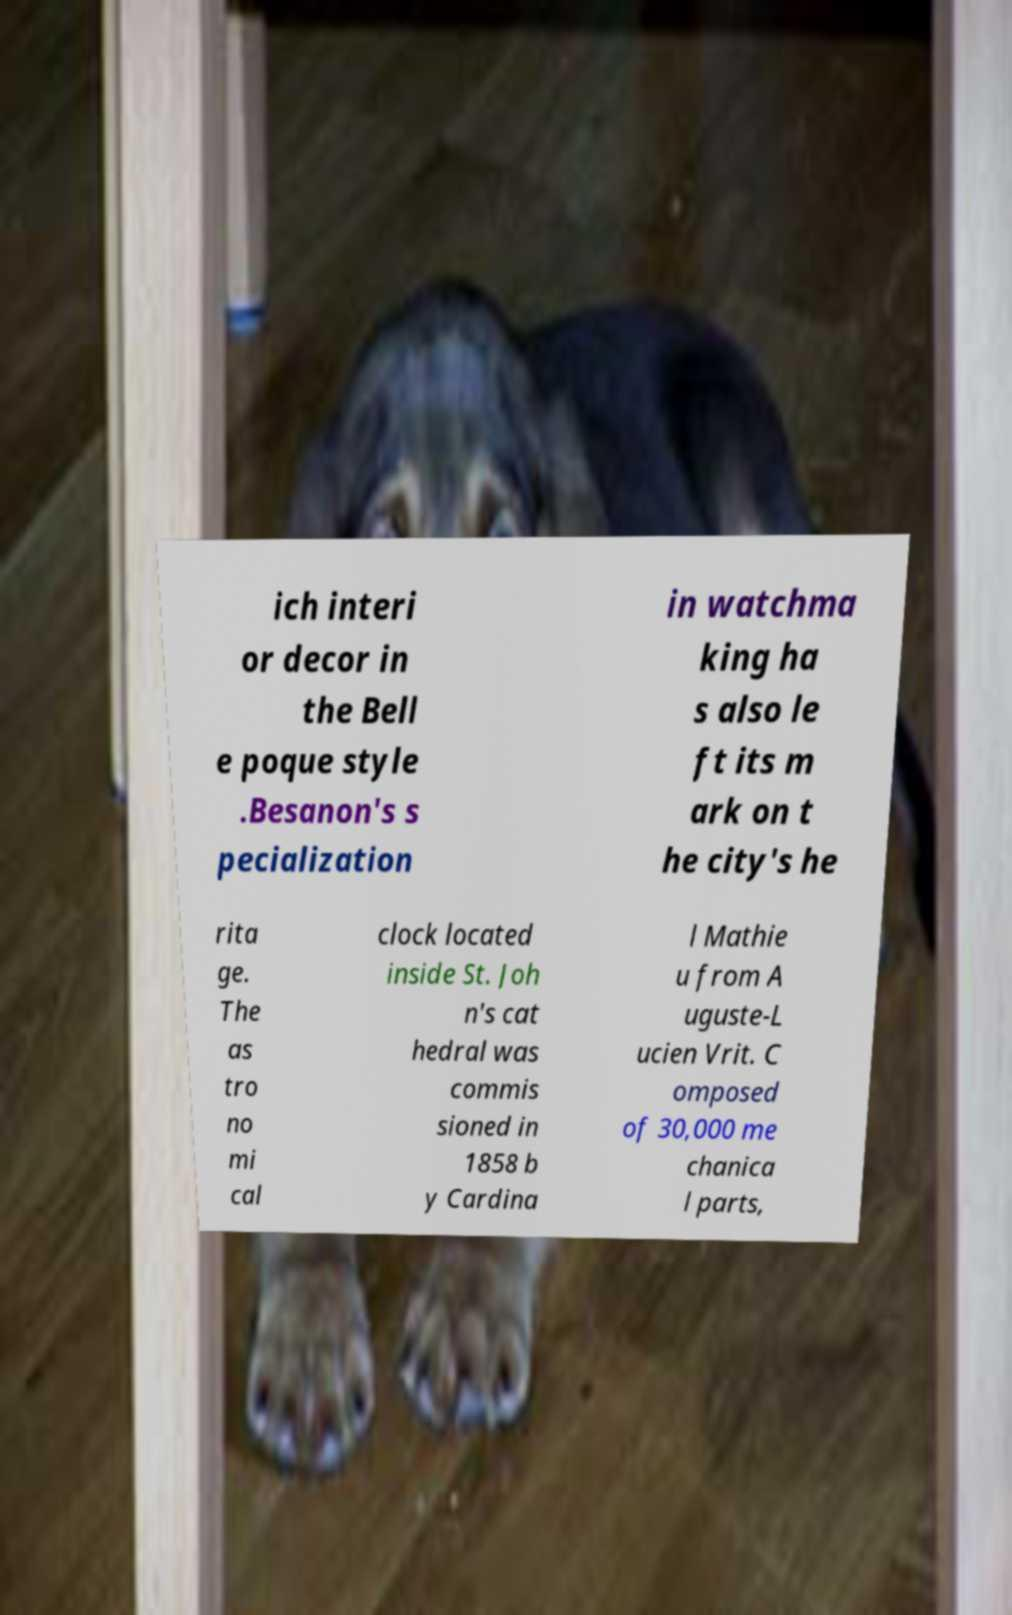I need the written content from this picture converted into text. Can you do that? ich interi or decor in the Bell e poque style .Besanon's s pecialization in watchma king ha s also le ft its m ark on t he city's he rita ge. The as tro no mi cal clock located inside St. Joh n's cat hedral was commis sioned in 1858 b y Cardina l Mathie u from A uguste-L ucien Vrit. C omposed of 30,000 me chanica l parts, 